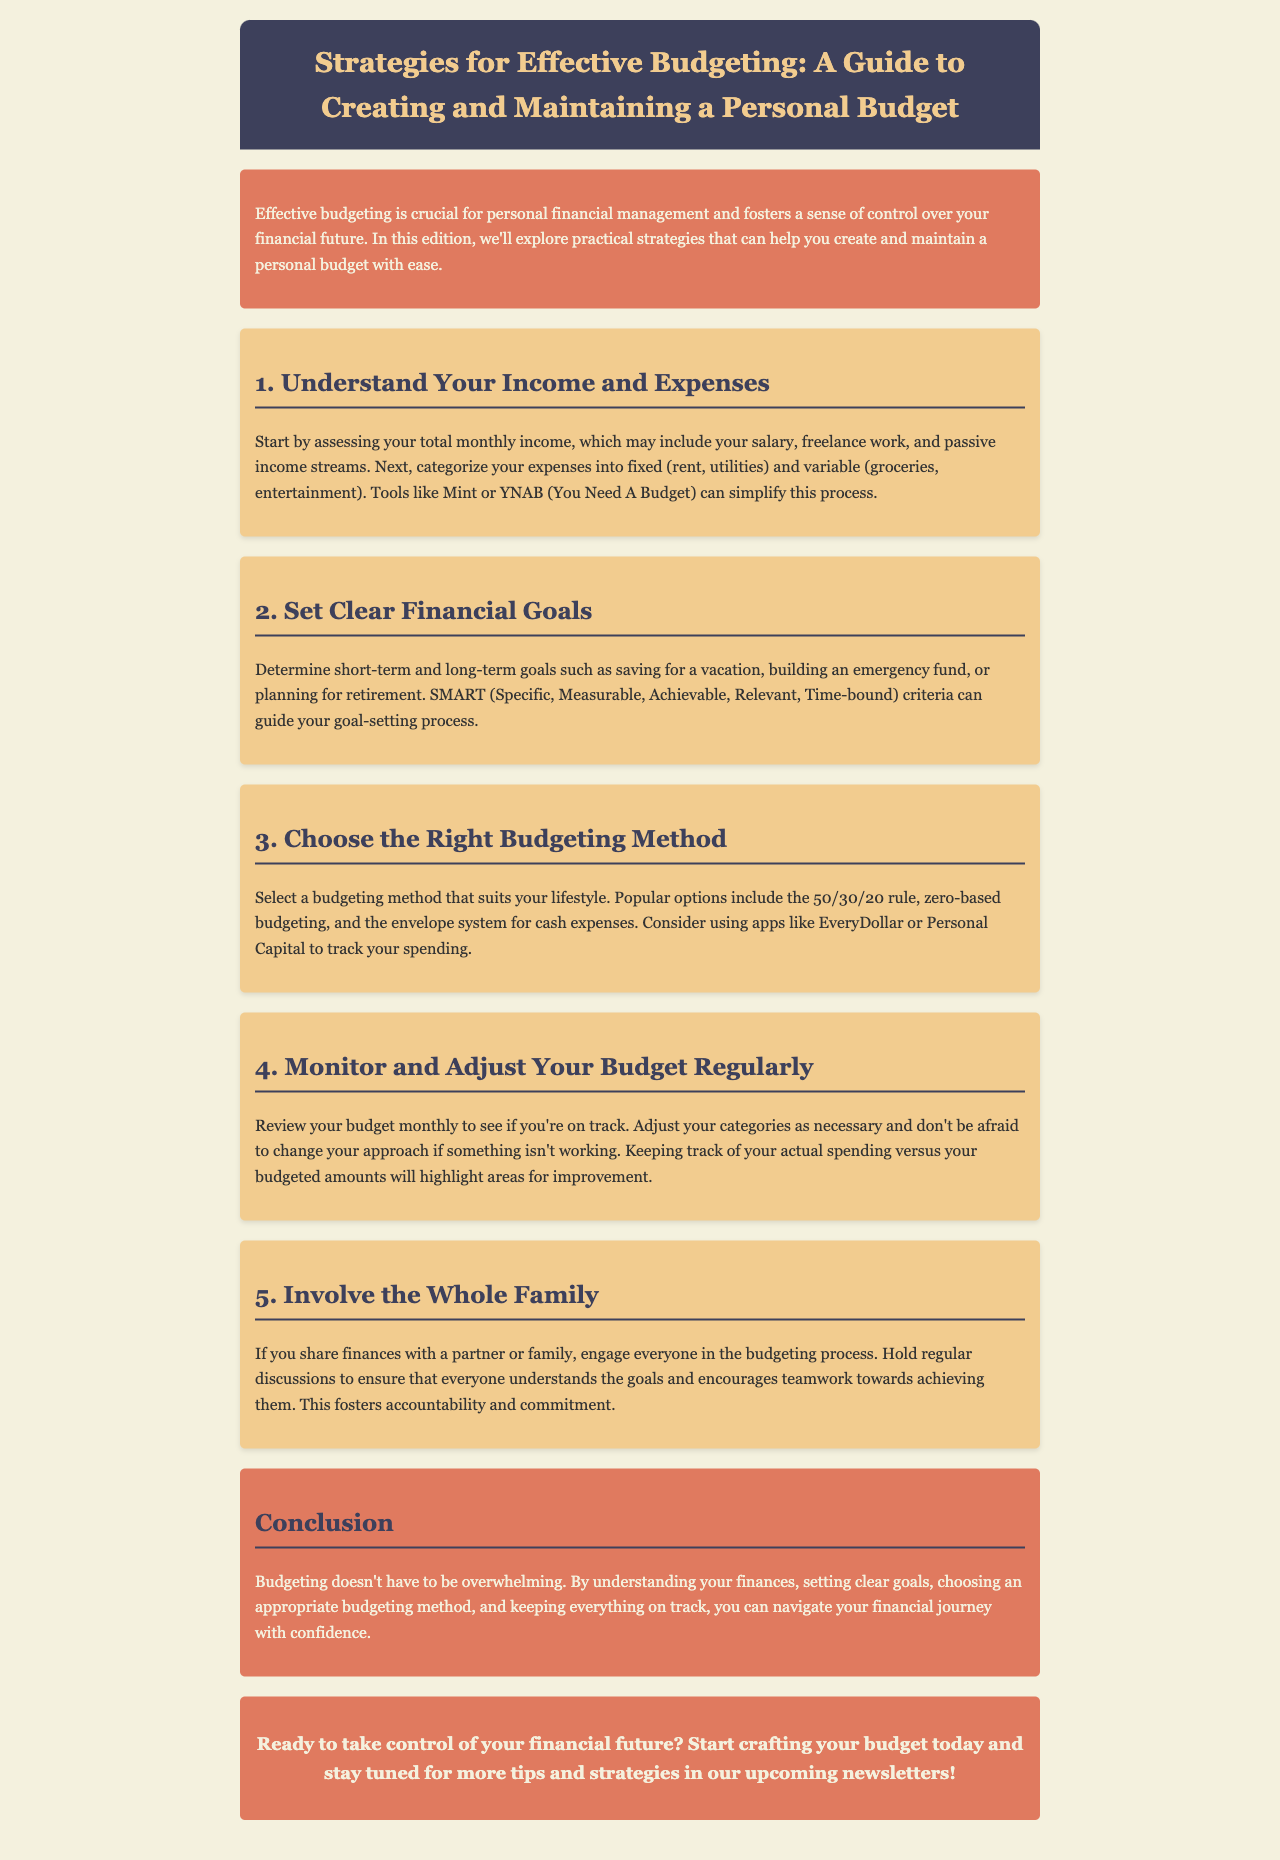What is the title of the newsletter? The title is found in the header section of the document, stating the focus on budgeting strategies.
Answer: Strategies for Effective Budgeting: A Guide to Creating and Maintaining a Personal Budget What is the first step to effective budgeting? The document mentions the first step in a numbered section, focusing on understanding income and expenses.
Answer: Understand Your Income and Expenses What budgeting method involves fixed and variable expenses? This method is described in the section detailing the understanding of income and expenses.
Answer: Budgeting Method What does SMART stand for regarding financial goals? The acronym SMART is explained in the section about setting clear financial goals and lists the criteria for setting those goals.
Answer: Specific, Measurable, Achievable, Relevant, Time-bound How often should you review your budget? The document suggests reviewing the budget monthly in the section on monitoring and adjusting your budget.
Answer: Monthly What is the purpose of involving the family in budgeting? The reason for family involvement is described in the section focusing on engagement and accountability among family members.
Answer: Accountability and commitment What color is used for the intro and conclusion sections? The color of these sections is consistent throughout the document, noted in the style segment for those specific parts.
Answer: e07a5f What is the main theme of the newsletter? The overall theme of the document revolves around personal financial management through budgeting strategies.
Answer: Effective budgeting strategies 